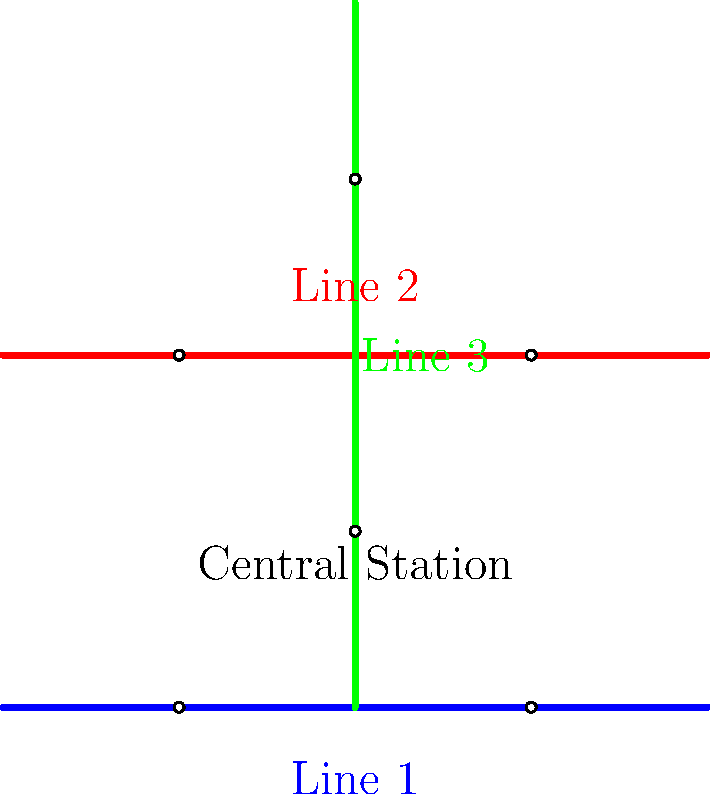Based on the simplified diagram of Chongqing's light rail transit system, which line appears to have the most potential for reducing travel time across the city, and why? To answer this question, we need to analyze the layout of the light rail system shown in the diagram:

1. The diagram shows three lines:
   - Line 1 (blue) running horizontally at the bottom
   - Line 2 (red) running horizontally at the top
   - Line 3 (green) running vertically in the middle

2. Key observations:
   - Line 3 intersects with both Line 1 and Line 2
   - The central station is located at the intersection of Line 1 and Line 3

3. Analysis of each line:
   - Line 1 and Line 2 run parallel to each other, covering the east-west direction
   - Line 3 runs perpendicular to Lines 1 and 2, covering the north-south direction

4. Efficiency considerations:
   - Line 3 connects both horizontal lines, allowing for transfers between all three lines
   - The central location of Line 3 means it can facilitate movement between different parts of the city more effectively

5. Travel time reduction:
   - Line 3's vertical orientation allows it to connect different areas of the city that would otherwise require multiple transfers or longer routes
   - It provides a direct north-south route, which can significantly reduce travel times for passengers moving between these areas

6. Conclusion:
   Line 3 appears to have the most potential for reducing travel time across the city because of its central location, connections to other lines, and ability to provide efficient north-south travel.
Answer: Line 3, due to its central vertical orientation connecting both horizontal lines and facilitating efficient north-south travel. 